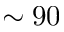<formula> <loc_0><loc_0><loc_500><loc_500>\sim 9 0</formula> 